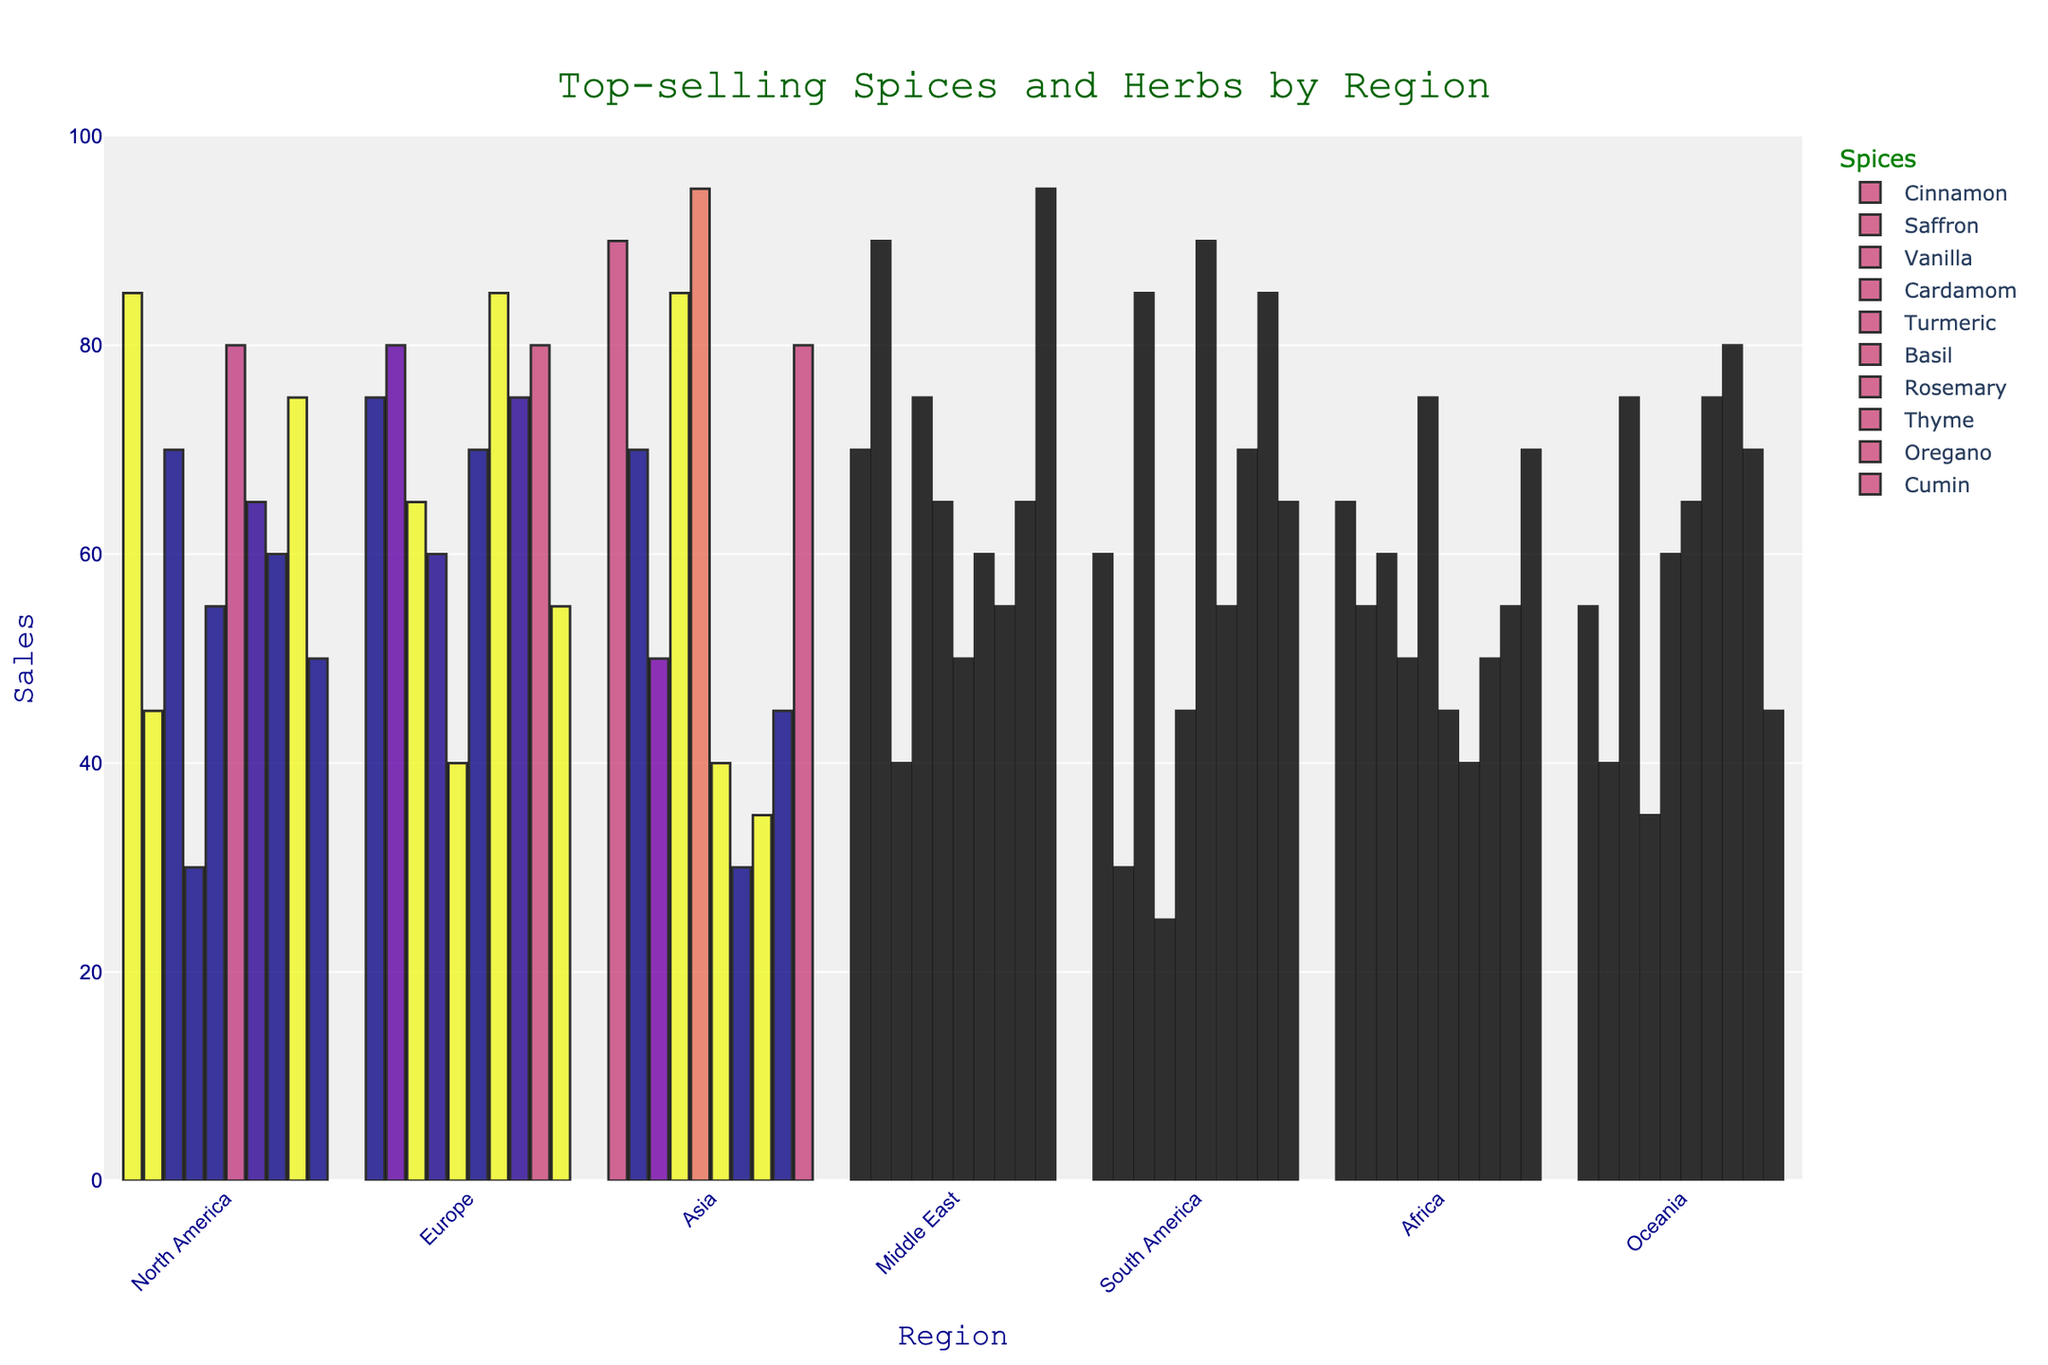Which region has the highest sales of Cardamom? Looking at the figure, identify the region with the tallest bar for Cardamom. Asia has the tallest bar for Cardamom.
Answer: Asia What's the total sales of Cinnamon and Vanilla in North America? Find the bars for Cinnamon and Vanilla in North America and sum their values. Cinnamon (85) + Vanilla (70) = 155.
Answer: 155 Which region sells more Turmeric: Europe or Africa? Compare the heights of the Turmeric bars for Europe and Africa. Europe (40) has a shorter bar than Africa (75).
Answer: Africa In which region is Basil the most popular? Identify the region with the tallest bar for Basil. South America has the tallest bar for Basil.
Answer: South America What’s the difference in sales between Saffron in Europe and Saffron in Oceania? Refer to the Saffron bars for Europe (80) and Oceania (40) and calculate the difference. 80 - 40 = 40.
Answer: 40 What is the average sales of Oregano across all regions? Sum up the sales of Oregano across all regions and divide by the number of regions. 75 + 80 + 45 + 65 + 85 + 55 + 70 = 475. Then, 475 / 7 ≈ 68.
Answer: 68 Which region has the least sales of Vanilla? Identify the region with the shortest bar for Vanilla. Middle East has the shortest bar for Vanilla.
Answer: Middle East Is the sales of Cumin in Asia more than the sales of Cinnamon in Oceania? Compare the Cumin bar for Asia (80) with the Cinnamon bar for Oceania (55). 80 is greater than 55.
Answer: Yes What’s the combined sales of Thyme in North America and South America? Find the bars for Thyme in North America (60) and South America (70), then sum the values. 60 + 70 = 130.
Answer: 130 How much more Rosemary is sold in Europe compared to Asia? Refer to the Rosemary bars for Europe (85) and Asia (30) and calculate the difference. 85 - 30 = 55.
Answer: 55 